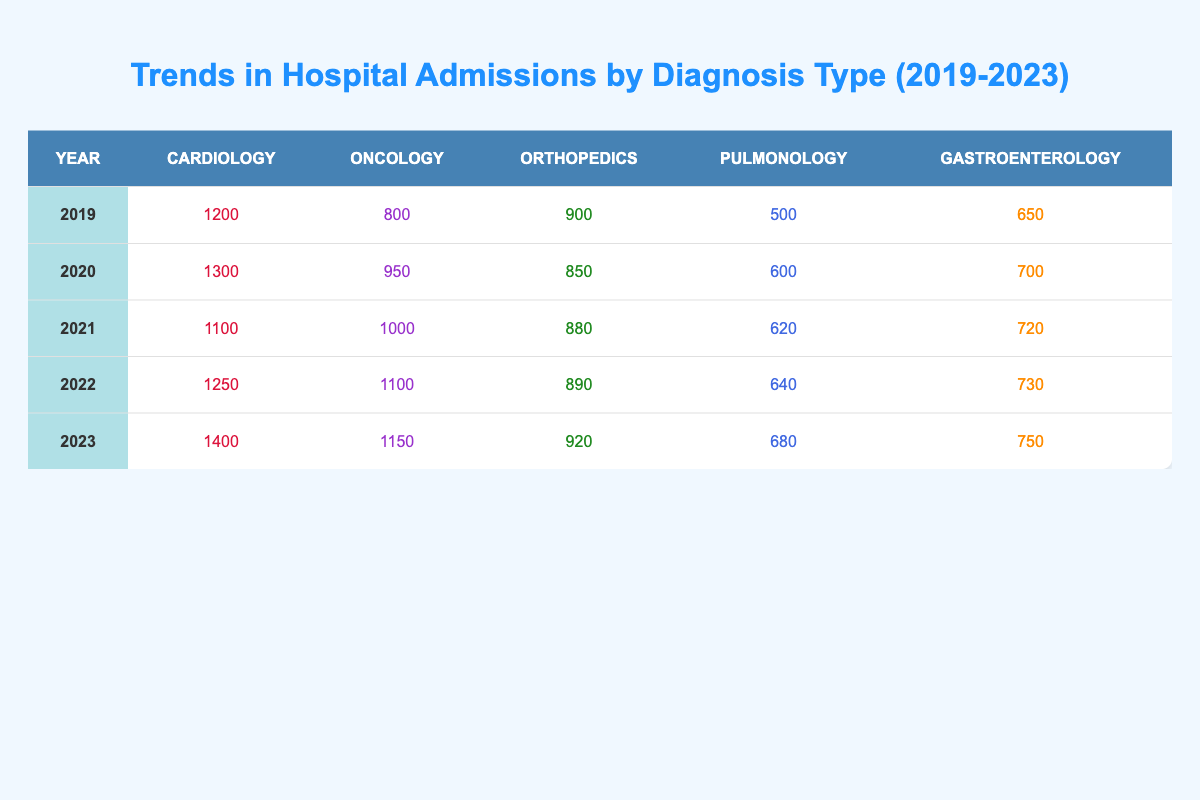What was the total number of cardiology admissions in 2022? In 2022, the cardiology admissions are listed as 1250. Since we are looking for the total for that single year, it's simply taken directly from the table.
Answer: 1250 Which year had the highest number of oncology admissions? By examining the table, we can see that the highest number of oncology admissions was in 2023 with a total of 1150.
Answer: 2023 How many total admissions were there for orthopedics over the five years? Adding the orthopedic admissions for each year: 900 (2019) + 850 (2020) + 880 (2021) + 890 (2022) + 920 (2023) gives a total of 4430.
Answer: 4430 Did the total number of pulmonology admissions increase from 2019 to 2023? In 2019, the admissions were 500, while in 2023, they were 680. Comparing these two values shows an increase.
Answer: Yes What was the average number of gastroenterology admissions over the five years? To find the average, first, sum the admissions: 650 (2019) + 700 (2020) + 720 (2021) + 730 (2022) + 750 (2023) = 3850. Then, divide by the number of years (5): 3850 / 5 = 770.
Answer: 770 Which diagnosis type saw the largest increase in admissions from 2019 to 2023? By calculating the difference between 2019 and 2023 for each diagnosis type: Cardiology +200, Oncology +350, Orthopedics +20, Pulmonology +180, and Gastroenterology +100. The largest increase is in Oncology (+350).
Answer: Oncology How did the number of oncology admissions in 2021 compare to that in 2022? In 2021, oncology admissions were 1000, while in 2022 they increased to 1100. This indicates that there was an increase of 100 admissions from 2021 to 2022.
Answer: Increased What was the difference in cardiology admissions between the years 2020 and 2021? The admissions for cardiology in 2020 were 1300, while in 2021 they were 1100. The difference is calculated as 1300 - 1100 = 200.
Answer: 200 Which year had the lowest number of pulmonology admissions, and what was the count? Looking through the table, Pulmonology admissions were lowest in 2019 at 500. Therefore, the year is 2019 with a count of 500.
Answer: 2019, 500 If we look at the total admissions for all diagnosis types in 2023, what is that number? We sum the admissions for 2023: 1400 (Cardiology) + 1150 (Oncology) + 920 (Orthopedics) + 680 (Pulmonology) + 750 (Gastroenterology) totals to 3900.
Answer: 3900 